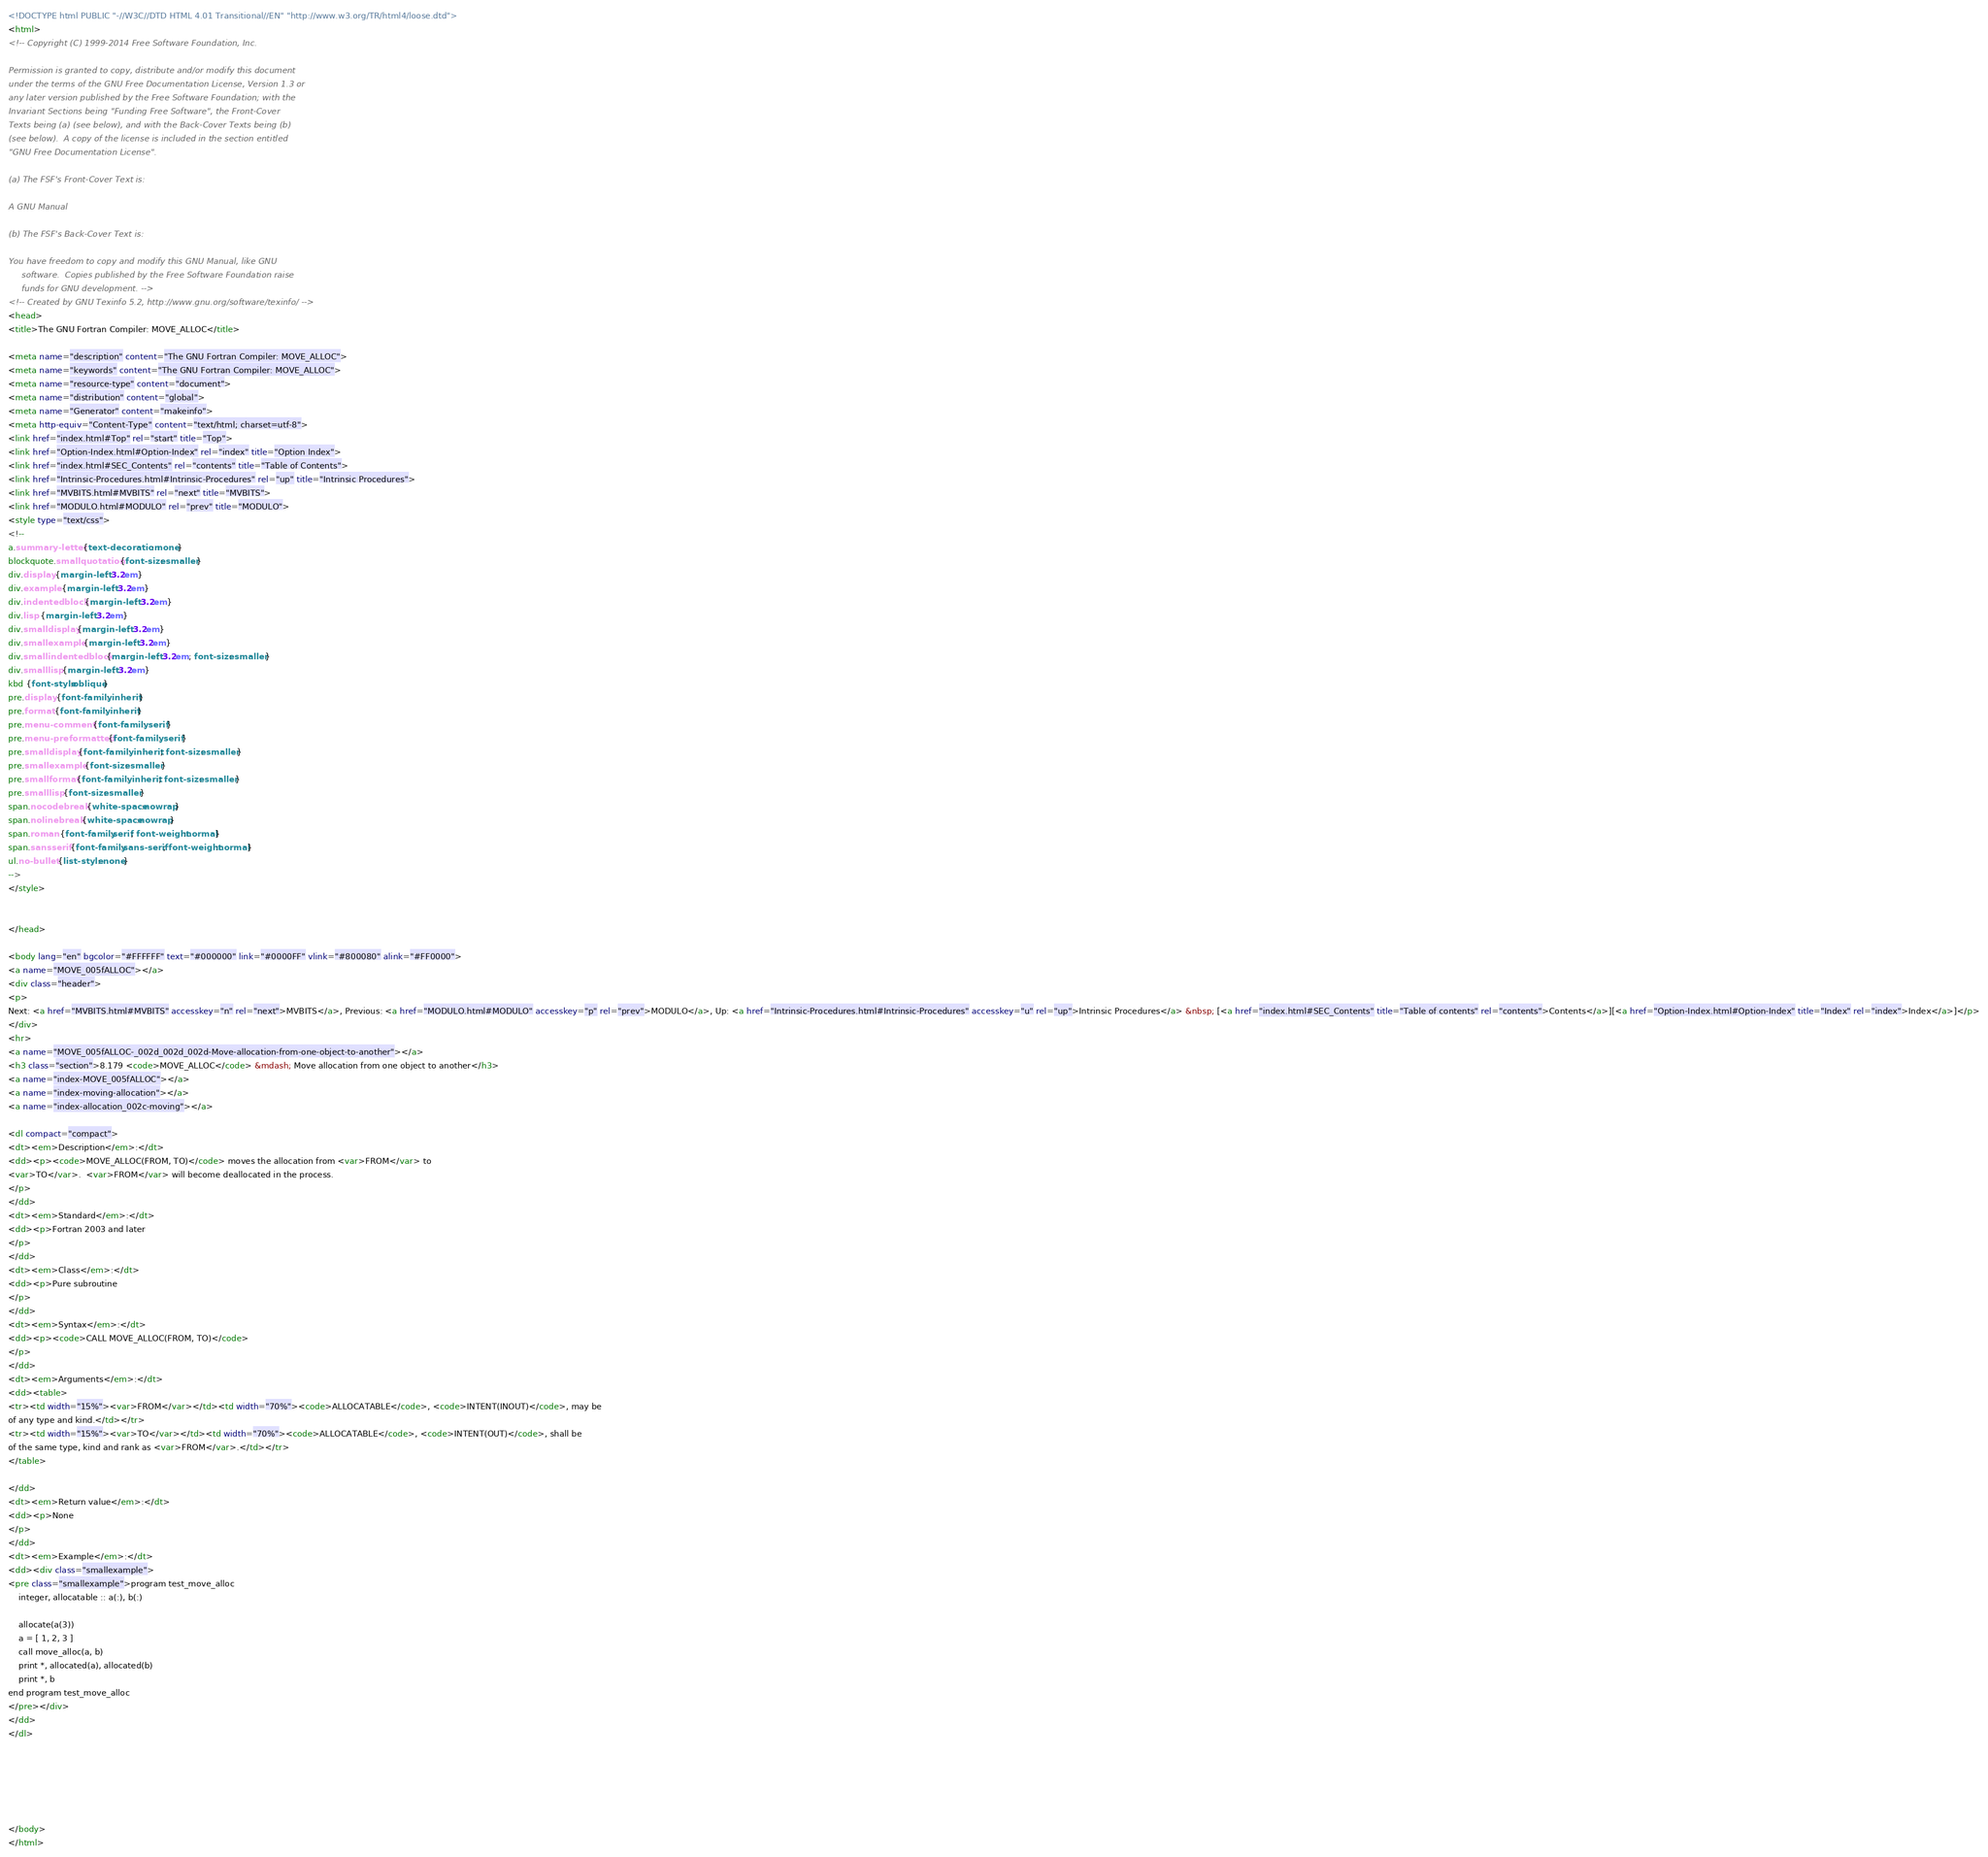Convert code to text. <code><loc_0><loc_0><loc_500><loc_500><_HTML_><!DOCTYPE html PUBLIC "-//W3C//DTD HTML 4.01 Transitional//EN" "http://www.w3.org/TR/html4/loose.dtd">
<html>
<!-- Copyright (C) 1999-2014 Free Software Foundation, Inc.

Permission is granted to copy, distribute and/or modify this document
under the terms of the GNU Free Documentation License, Version 1.3 or
any later version published by the Free Software Foundation; with the
Invariant Sections being "Funding Free Software", the Front-Cover
Texts being (a) (see below), and with the Back-Cover Texts being (b)
(see below).  A copy of the license is included in the section entitled
"GNU Free Documentation License".

(a) The FSF's Front-Cover Text is:

A GNU Manual

(b) The FSF's Back-Cover Text is:

You have freedom to copy and modify this GNU Manual, like GNU
     software.  Copies published by the Free Software Foundation raise
     funds for GNU development. -->
<!-- Created by GNU Texinfo 5.2, http://www.gnu.org/software/texinfo/ -->
<head>
<title>The GNU Fortran Compiler: MOVE_ALLOC</title>

<meta name="description" content="The GNU Fortran Compiler: MOVE_ALLOC">
<meta name="keywords" content="The GNU Fortran Compiler: MOVE_ALLOC">
<meta name="resource-type" content="document">
<meta name="distribution" content="global">
<meta name="Generator" content="makeinfo">
<meta http-equiv="Content-Type" content="text/html; charset=utf-8">
<link href="index.html#Top" rel="start" title="Top">
<link href="Option-Index.html#Option-Index" rel="index" title="Option Index">
<link href="index.html#SEC_Contents" rel="contents" title="Table of Contents">
<link href="Intrinsic-Procedures.html#Intrinsic-Procedures" rel="up" title="Intrinsic Procedures">
<link href="MVBITS.html#MVBITS" rel="next" title="MVBITS">
<link href="MODULO.html#MODULO" rel="prev" title="MODULO">
<style type="text/css">
<!--
a.summary-letter {text-decoration: none}
blockquote.smallquotation {font-size: smaller}
div.display {margin-left: 3.2em}
div.example {margin-left: 3.2em}
div.indentedblock {margin-left: 3.2em}
div.lisp {margin-left: 3.2em}
div.smalldisplay {margin-left: 3.2em}
div.smallexample {margin-left: 3.2em}
div.smallindentedblock {margin-left: 3.2em; font-size: smaller}
div.smalllisp {margin-left: 3.2em}
kbd {font-style:oblique}
pre.display {font-family: inherit}
pre.format {font-family: inherit}
pre.menu-comment {font-family: serif}
pre.menu-preformatted {font-family: serif}
pre.smalldisplay {font-family: inherit; font-size: smaller}
pre.smallexample {font-size: smaller}
pre.smallformat {font-family: inherit; font-size: smaller}
pre.smalllisp {font-size: smaller}
span.nocodebreak {white-space:nowrap}
span.nolinebreak {white-space:nowrap}
span.roman {font-family:serif; font-weight:normal}
span.sansserif {font-family:sans-serif; font-weight:normal}
ul.no-bullet {list-style: none}
-->
</style>


</head>

<body lang="en" bgcolor="#FFFFFF" text="#000000" link="#0000FF" vlink="#800080" alink="#FF0000">
<a name="MOVE_005fALLOC"></a>
<div class="header">
<p>
Next: <a href="MVBITS.html#MVBITS" accesskey="n" rel="next">MVBITS</a>, Previous: <a href="MODULO.html#MODULO" accesskey="p" rel="prev">MODULO</a>, Up: <a href="Intrinsic-Procedures.html#Intrinsic-Procedures" accesskey="u" rel="up">Intrinsic Procedures</a> &nbsp; [<a href="index.html#SEC_Contents" title="Table of contents" rel="contents">Contents</a>][<a href="Option-Index.html#Option-Index" title="Index" rel="index">Index</a>]</p>
</div>
<hr>
<a name="MOVE_005fALLOC-_002d_002d_002d-Move-allocation-from-one-object-to-another"></a>
<h3 class="section">8.179 <code>MOVE_ALLOC</code> &mdash; Move allocation from one object to another</h3>
<a name="index-MOVE_005fALLOC"></a>
<a name="index-moving-allocation"></a>
<a name="index-allocation_002c-moving"></a>

<dl compact="compact">
<dt><em>Description</em>:</dt>
<dd><p><code>MOVE_ALLOC(FROM, TO)</code> moves the allocation from <var>FROM</var> to
<var>TO</var>.  <var>FROM</var> will become deallocated in the process.
</p>
</dd>
<dt><em>Standard</em>:</dt>
<dd><p>Fortran 2003 and later
</p>
</dd>
<dt><em>Class</em>:</dt>
<dd><p>Pure subroutine
</p>
</dd>
<dt><em>Syntax</em>:</dt>
<dd><p><code>CALL MOVE_ALLOC(FROM, TO)</code>
</p>
</dd>
<dt><em>Arguments</em>:</dt>
<dd><table>
<tr><td width="15%"><var>FROM</var></td><td width="70%"><code>ALLOCATABLE</code>, <code>INTENT(INOUT)</code>, may be
of any type and kind.</td></tr>
<tr><td width="15%"><var>TO</var></td><td width="70%"><code>ALLOCATABLE</code>, <code>INTENT(OUT)</code>, shall be
of the same type, kind and rank as <var>FROM</var>.</td></tr>
</table>

</dd>
<dt><em>Return value</em>:</dt>
<dd><p>None
</p>
</dd>
<dt><em>Example</em>:</dt>
<dd><div class="smallexample">
<pre class="smallexample">program test_move_alloc
    integer, allocatable :: a(:), b(:)

    allocate(a(3))
    a = [ 1, 2, 3 ]
    call move_alloc(a, b)
    print *, allocated(a), allocated(b)
    print *, b
end program test_move_alloc
</pre></div>
</dd>
</dl>






</body>
</html>
</code> 